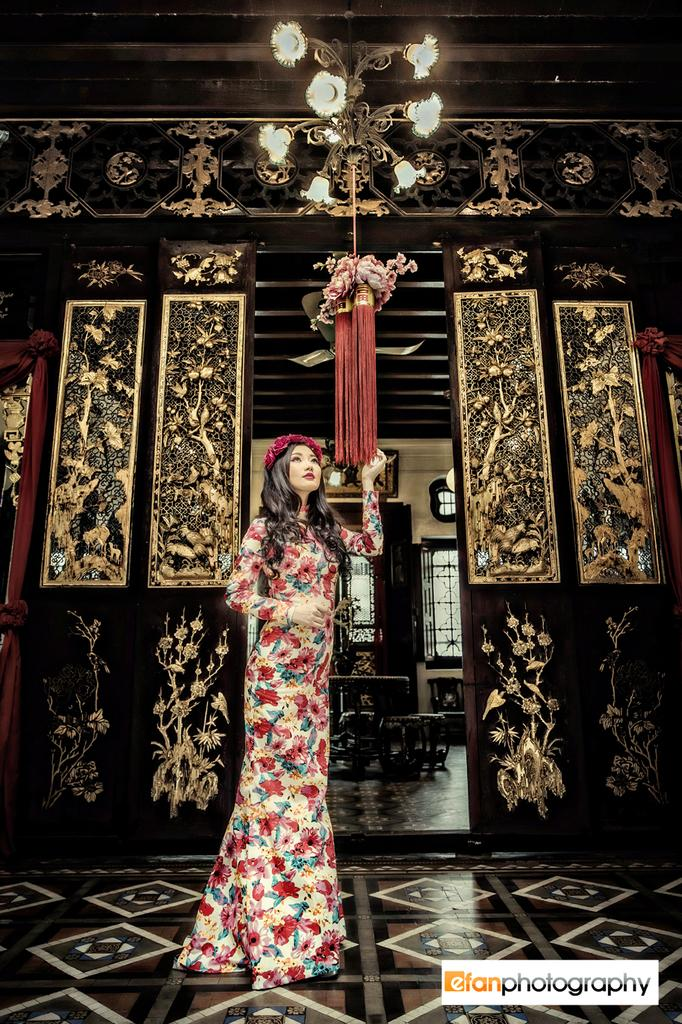Who is the main subject in the image? There is a girl in the image. What can be seen in the background of the image? There are frames in the background of the image. What type of decoration is visible at the top of the image? There is ceiling decor visible at the top of the image. Can you tell me how many squirrels are hiding in the girl's pocket in the image? There are no squirrels present in the image, and the girl is not shown with any pockets. 